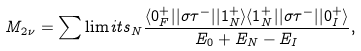<formula> <loc_0><loc_0><loc_500><loc_500>M _ { 2 \nu } = \sum \lim i t s _ { N } \frac { \langle 0 _ { F } ^ { + } | | \sigma \tau ^ { - } | | 1 _ { N } ^ { + } \rangle \langle 1 _ { N } ^ { + } | | \sigma \tau ^ { - } | | 0 _ { I } ^ { + } \rangle } { E _ { 0 } + E _ { N } - E _ { I } } ,</formula> 